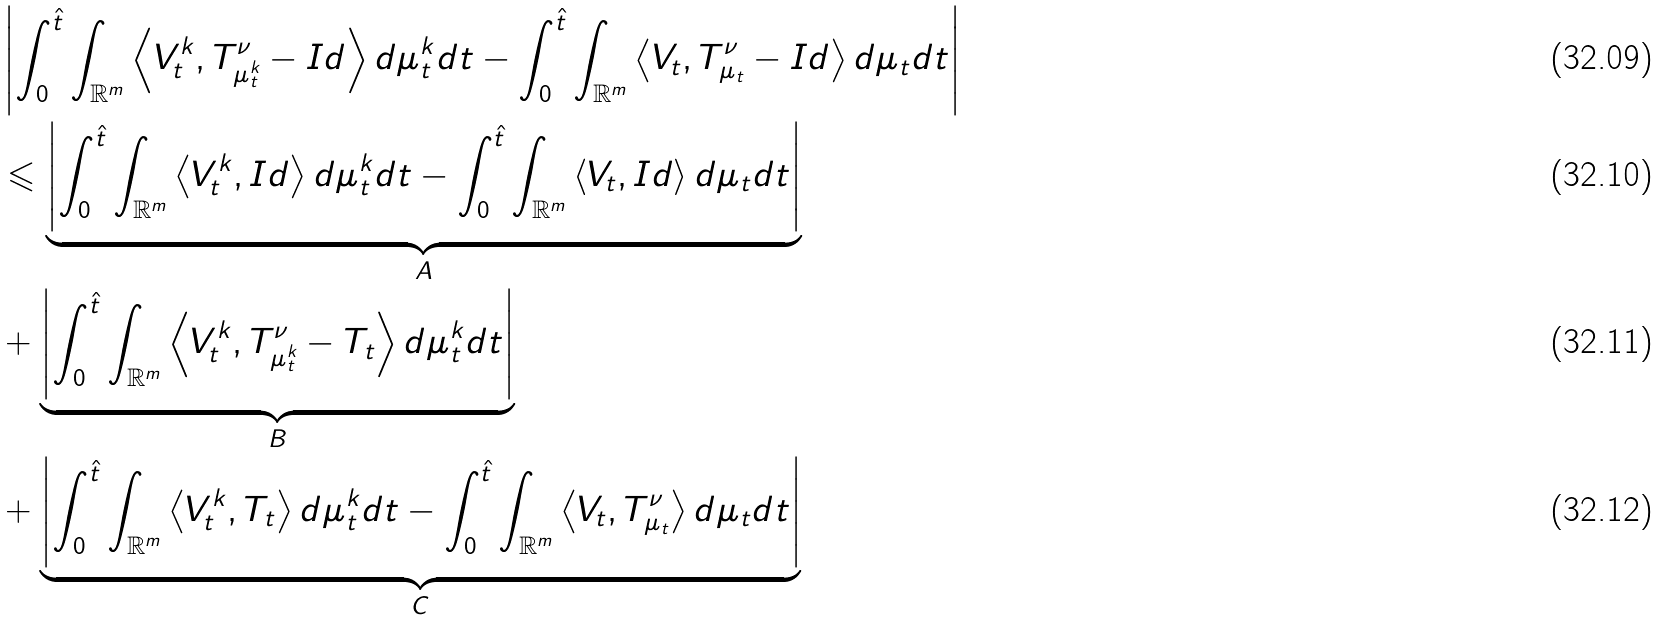Convert formula to latex. <formula><loc_0><loc_0><loc_500><loc_500>& \left | \int _ { 0 } ^ { \hat { t } } \int _ { \mathbb { R } ^ { m } } \left \langle V _ { t } ^ { k } , T _ { \mu _ { t } ^ { k } } ^ { \nu } - I d \right \rangle d \mu _ { t } ^ { k } d t - \int _ { 0 } ^ { \hat { t } } \int _ { \mathbb { R } ^ { m } } \left \langle V _ { t } , T _ { \mu _ { t } } ^ { \nu } - I d \right \rangle d \mu _ { t } d t \right | \\ & \leqslant \underbrace { \left | \int _ { 0 } ^ { \hat { t } } \int _ { \mathbb { R } ^ { m } } \left \langle V _ { t } ^ { k } , I d \right \rangle d \mu _ { t } ^ { k } d t - \int _ { 0 } ^ { \hat { t } } \int _ { \mathbb { R } ^ { m } } \left \langle V _ { t } , I d \right \rangle d \mu _ { t } d t \right | } _ { A } \\ & + \underbrace { \left | \int _ { 0 } ^ { \hat { t } } \int _ { \mathbb { R } ^ { m } } \left \langle V _ { t } ^ { k } , T _ { \mu _ { t } ^ { k } } ^ { \nu } - T _ { t } \right \rangle d \mu _ { t } ^ { k } d t \right | } _ { B } \\ & + \underbrace { \left | \int _ { 0 } ^ { \hat { t } } \int _ { \mathbb { R } ^ { m } } \left \langle V _ { t } ^ { k } , T _ { t } \right \rangle d \mu _ { t } ^ { k } d t - \int _ { 0 } ^ { \hat { t } } \int _ { \mathbb { R } ^ { m } } \left \langle V _ { t } , T _ { \mu _ { t } } ^ { \nu } \right \rangle d \mu _ { t } d t \right | } _ { C }</formula> 